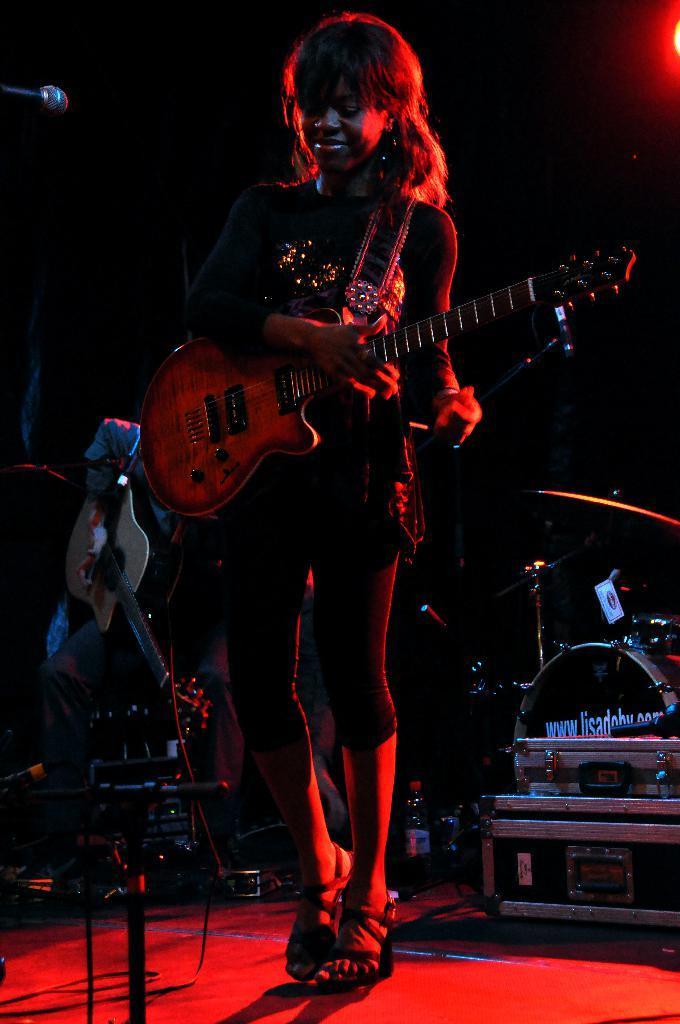In one or two sentences, can you explain what this image depicts? In this picture there is a lady in black dress holding a guitar and playing it in front of the mic and behind her there is a man who is playing the musical instrument. 